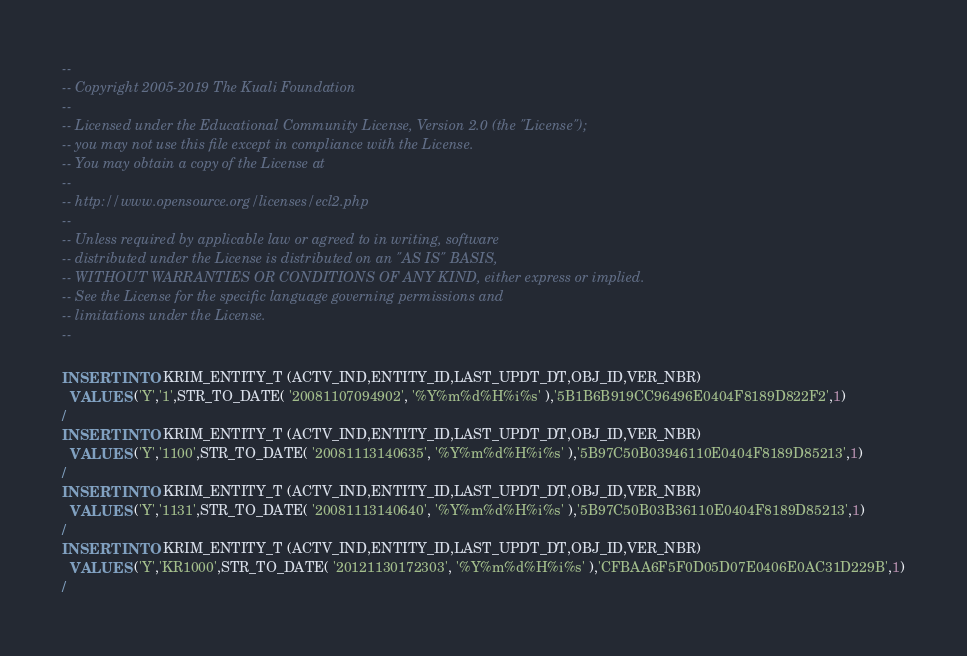Convert code to text. <code><loc_0><loc_0><loc_500><loc_500><_SQL_>--
-- Copyright 2005-2019 The Kuali Foundation
--
-- Licensed under the Educational Community License, Version 2.0 (the "License");
-- you may not use this file except in compliance with the License.
-- You may obtain a copy of the License at
--
-- http://www.opensource.org/licenses/ecl2.php
--
-- Unless required by applicable law or agreed to in writing, software
-- distributed under the License is distributed on an "AS IS" BASIS,
-- WITHOUT WARRANTIES OR CONDITIONS OF ANY KIND, either express or implied.
-- See the License for the specific language governing permissions and
-- limitations under the License.
--

INSERT INTO KRIM_ENTITY_T (ACTV_IND,ENTITY_ID,LAST_UPDT_DT,OBJ_ID,VER_NBR)
  VALUES ('Y','1',STR_TO_DATE( '20081107094902', '%Y%m%d%H%i%s' ),'5B1B6B919CC96496E0404F8189D822F2',1)
/
INSERT INTO KRIM_ENTITY_T (ACTV_IND,ENTITY_ID,LAST_UPDT_DT,OBJ_ID,VER_NBR)
  VALUES ('Y','1100',STR_TO_DATE( '20081113140635', '%Y%m%d%H%i%s' ),'5B97C50B03946110E0404F8189D85213',1)
/
INSERT INTO KRIM_ENTITY_T (ACTV_IND,ENTITY_ID,LAST_UPDT_DT,OBJ_ID,VER_NBR)
  VALUES ('Y','1131',STR_TO_DATE( '20081113140640', '%Y%m%d%H%i%s' ),'5B97C50B03B36110E0404F8189D85213',1)
/
INSERT INTO KRIM_ENTITY_T (ACTV_IND,ENTITY_ID,LAST_UPDT_DT,OBJ_ID,VER_NBR)
  VALUES ('Y','KR1000',STR_TO_DATE( '20121130172303', '%Y%m%d%H%i%s' ),'CFBAA6F5F0D05D07E0406E0AC31D229B',1)
/
</code> 